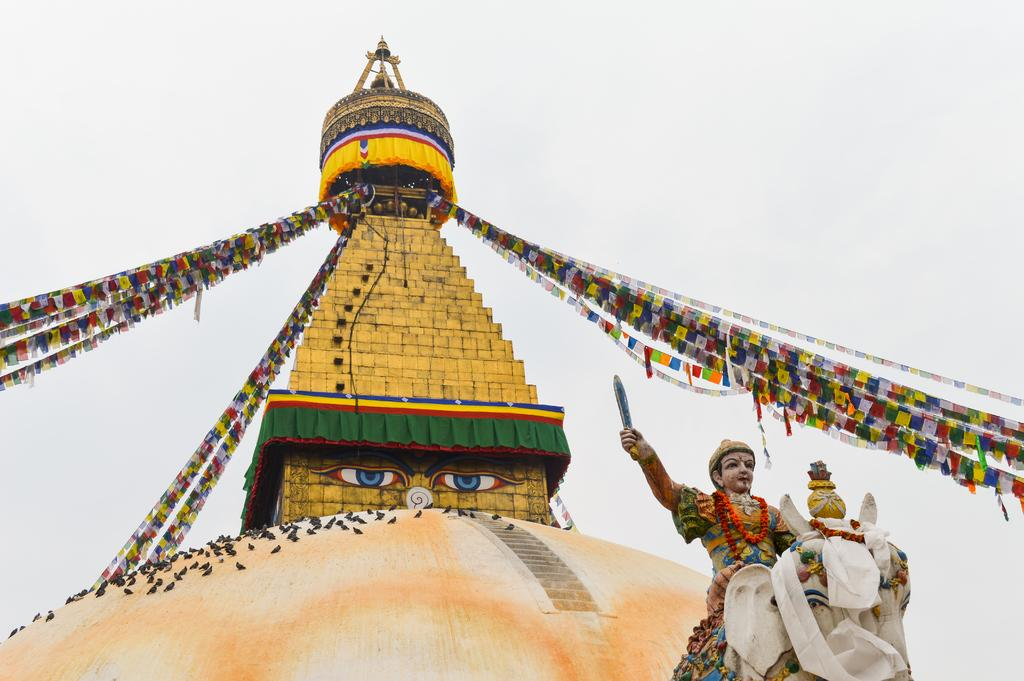What type of structure is present in the image? There is a dome in the image. What other object can be seen in the image? There is a statue in the image. What can be seen in the background of the image? The sky is visible in the background of the image. How long does it take for the statue to improve its health in the image? There is no indication of the statue's health or any changes to it in the image. 